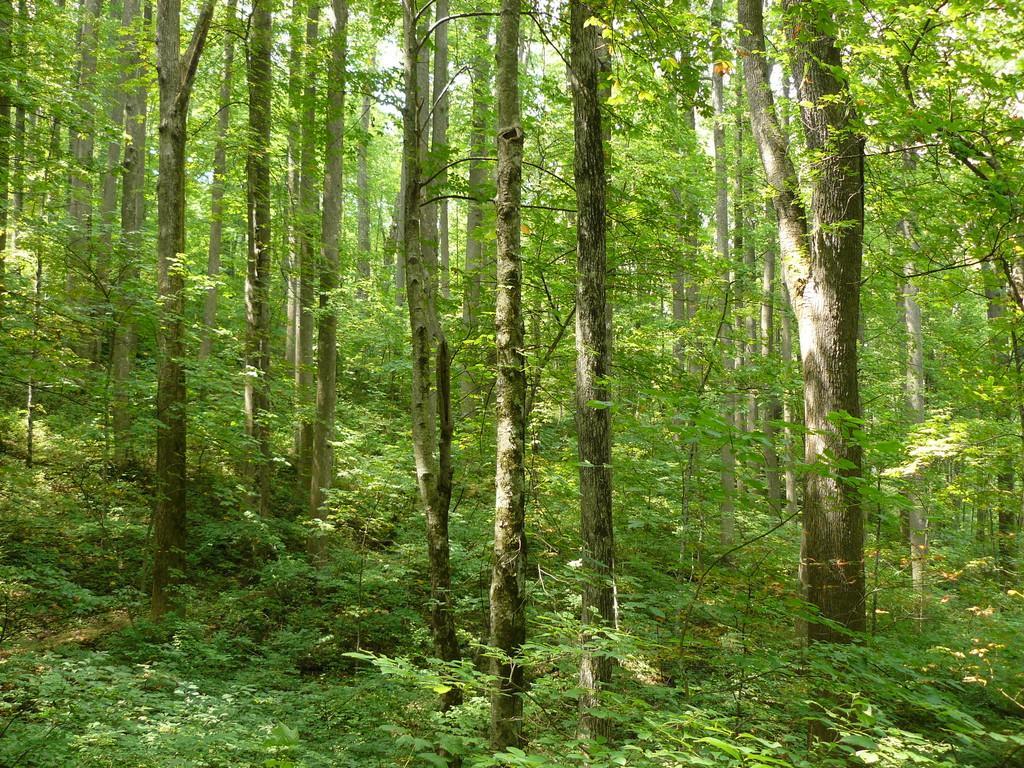Could you give a brief overview of what you see in this image? In this picture I can see trees and few plants and I can see sky. 